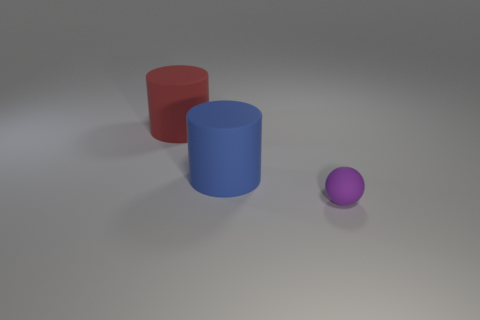Subtract all balls. How many objects are left? 2 Add 3 large blue objects. How many objects exist? 6 Subtract all big red objects. Subtract all tiny purple rubber balls. How many objects are left? 1 Add 2 purple rubber spheres. How many purple rubber spheres are left? 3 Add 2 blue things. How many blue things exist? 3 Subtract 1 purple balls. How many objects are left? 2 